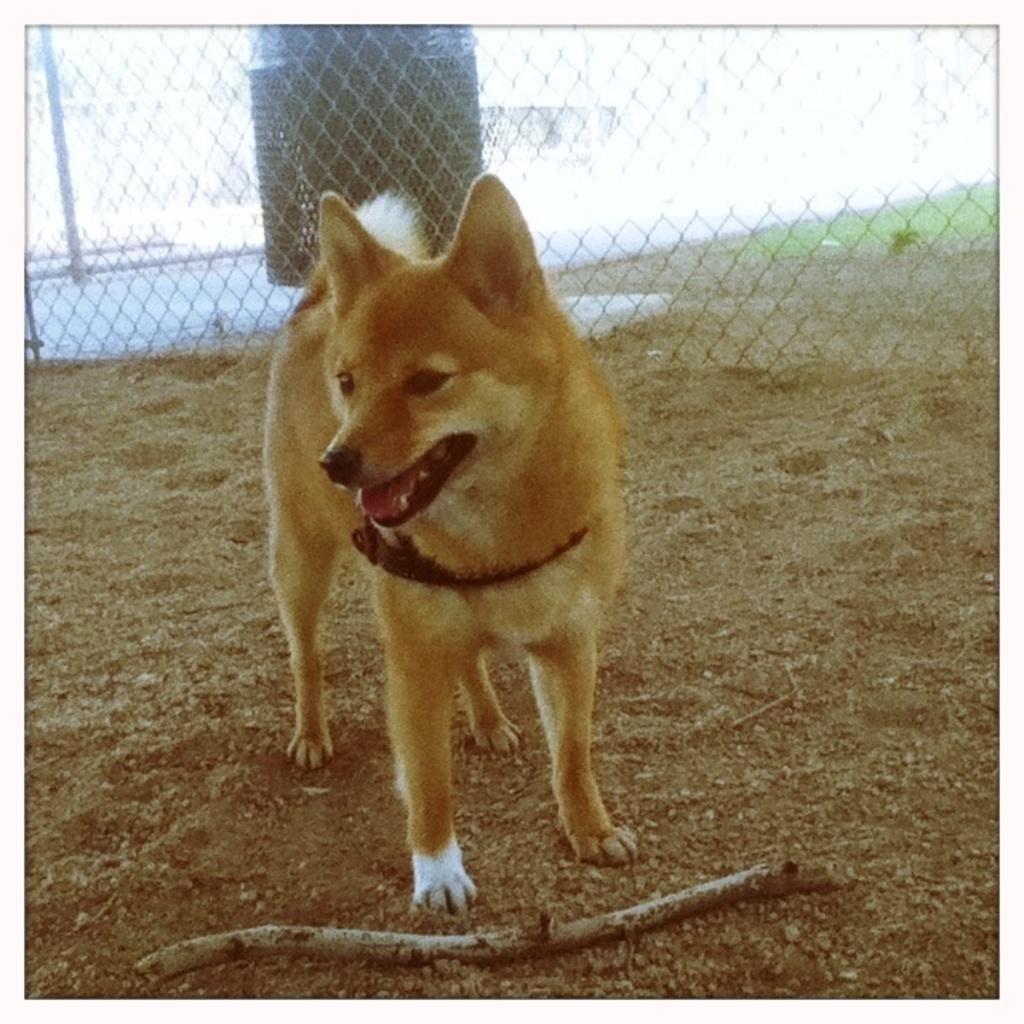What type of animal is in the image? There is a dog in the image. Can you describe the appearance of the dog? The dog is brown and white in color. What object is in front of the dog? There is a wooden stick in front of the dog. What can be seen in the background of the image? There is a railing visible in the background of the image. What day of the week is depicted in the image? The image does not depict a specific day of the week; it is a still photograph. 